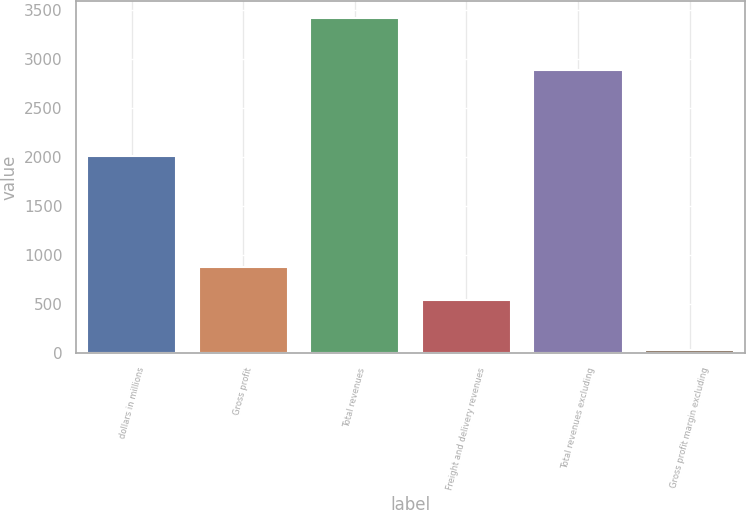Convert chart. <chart><loc_0><loc_0><loc_500><loc_500><bar_chart><fcel>dollars in millions<fcel>Gross profit<fcel>Total revenues<fcel>Freight and delivery revenues<fcel>Total revenues excluding<fcel>Gross profit margin excluding<nl><fcel>2015<fcel>877.35<fcel>3422.2<fcel>538.1<fcel>2884.1<fcel>29.7<nl></chart> 